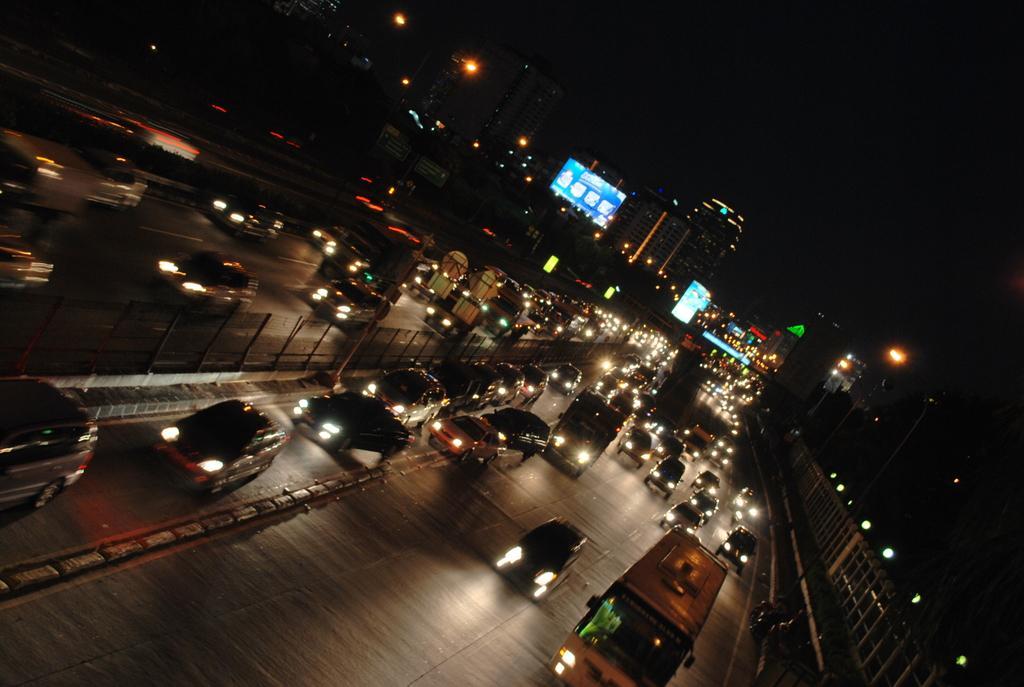How would you summarize this image in a sentence or two? In this picture we can see vehicles on the road and in the background we can see buildings, lights, boards, sky and some objects. 